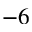<formula> <loc_0><loc_0><loc_500><loc_500>^ { - 6 }</formula> 